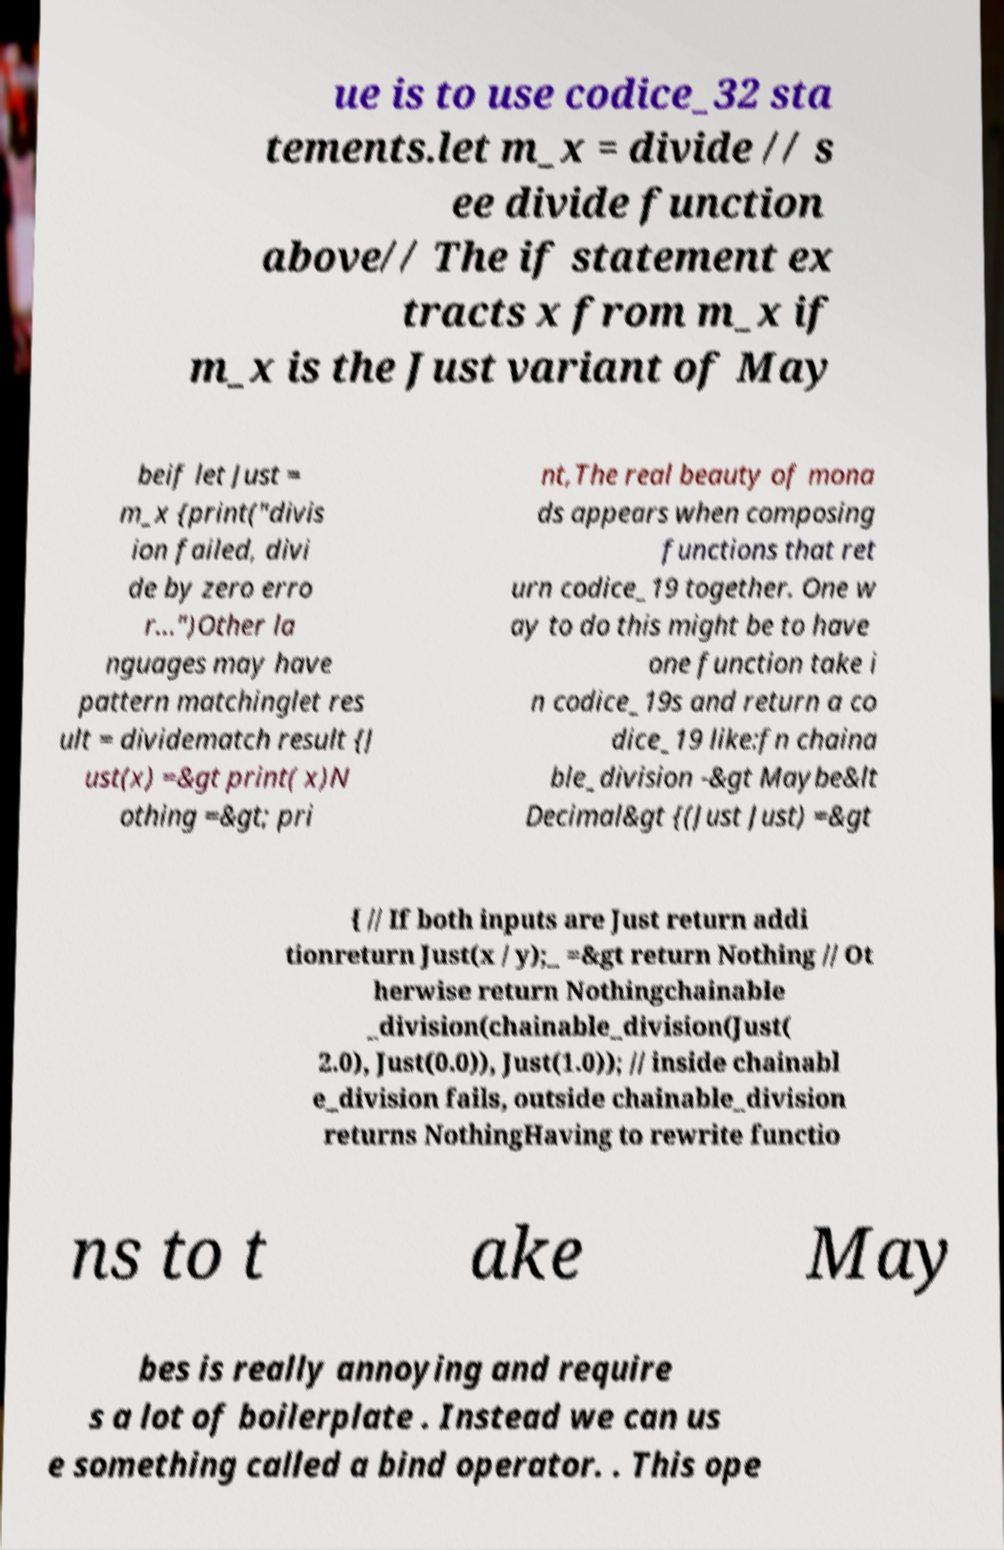What messages or text are displayed in this image? I need them in a readable, typed format. ue is to use codice_32 sta tements.let m_x = divide // s ee divide function above// The if statement ex tracts x from m_x if m_x is the Just variant of May beif let Just = m_x {print("divis ion failed, divi de by zero erro r...")Other la nguages may have pattern matchinglet res ult = dividematch result {J ust(x) =&gt print( x)N othing =&gt; pri nt,The real beauty of mona ds appears when composing functions that ret urn codice_19 together. One w ay to do this might be to have one function take i n codice_19s and return a co dice_19 like:fn chaina ble_division -&gt Maybe&lt Decimal&gt {(Just Just) =&gt { // If both inputs are Just return addi tionreturn Just(x / y);_ =&gt return Nothing // Ot herwise return Nothingchainable _division(chainable_division(Just( 2.0), Just(0.0)), Just(1.0)); // inside chainabl e_division fails, outside chainable_division returns NothingHaving to rewrite functio ns to t ake May bes is really annoying and require s a lot of boilerplate . Instead we can us e something called a bind operator. . This ope 